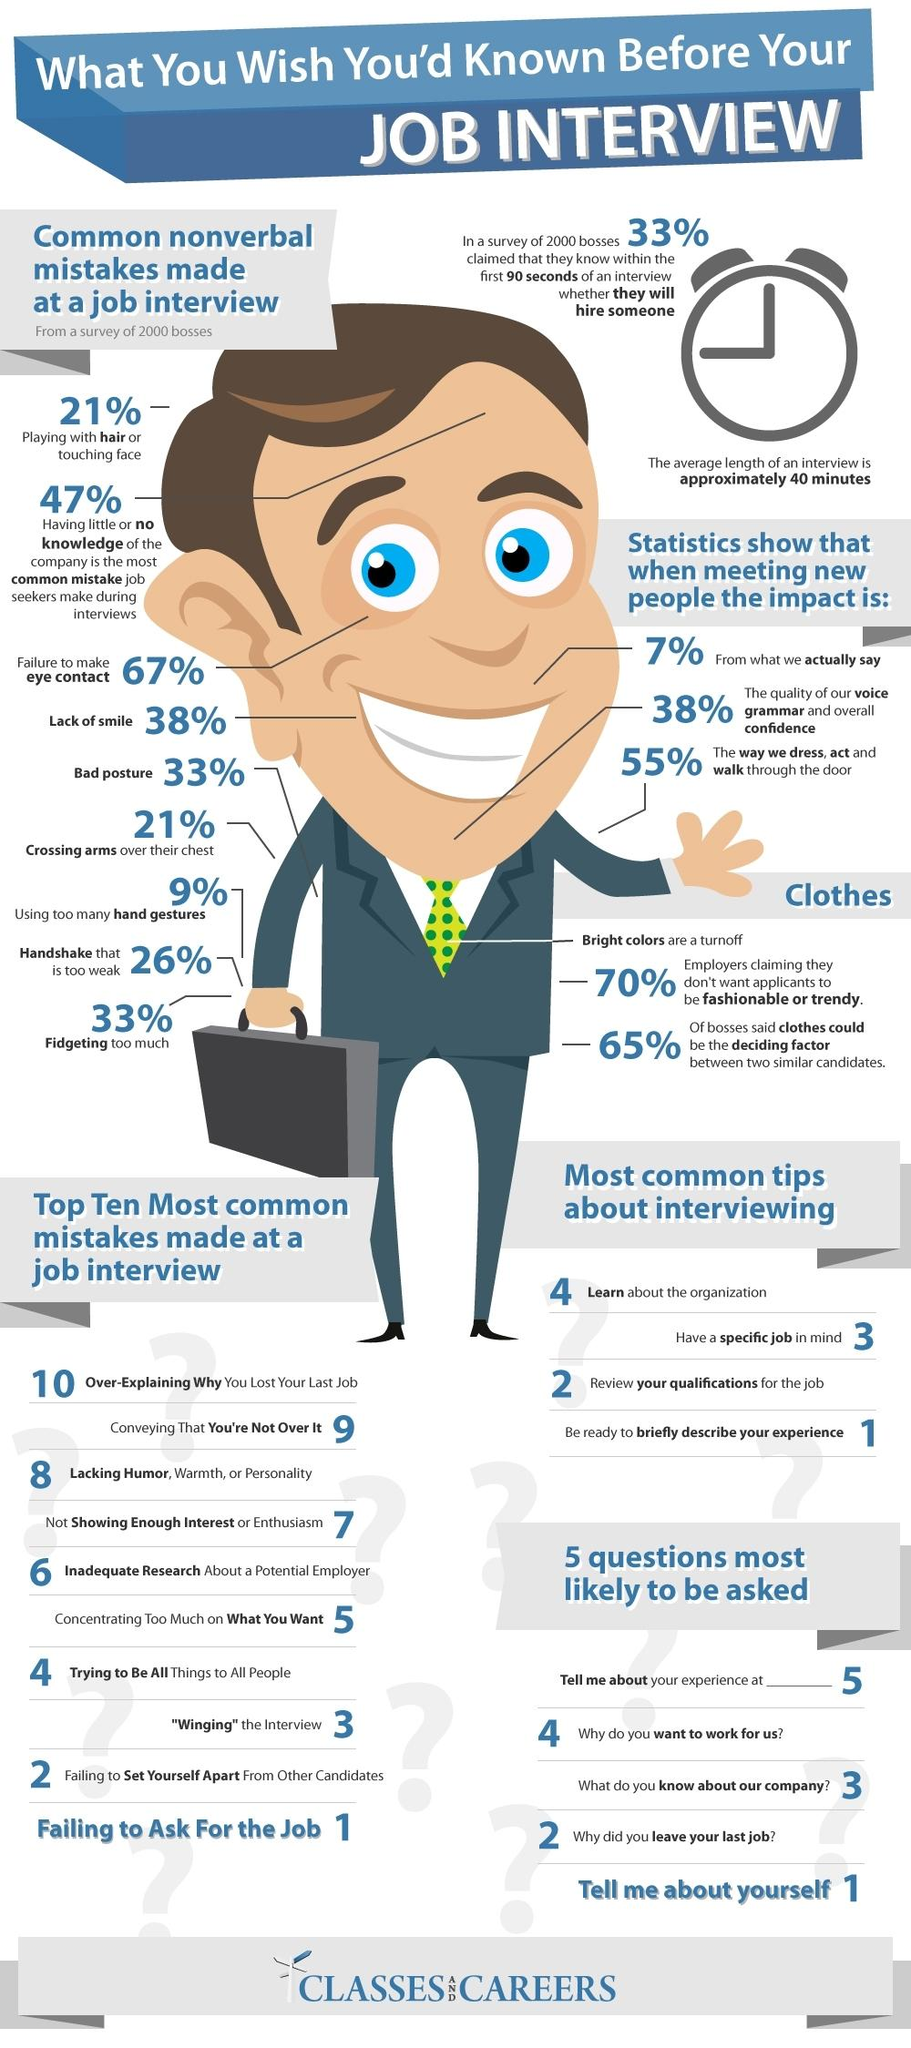Identify some key points in this picture. The most common mistake of job seekers is a lack of knowledge about the company they are applying to, which hinders their chances of landing the job. The most common mistake made during a job interview is failing to ask for the job. The inverse of people who lack a smile during an interview is 62%. It is not appropriate to engage in activities such as playing with hair during a job interview. It is appropriate to wear light-colored clothing for a job interview. 